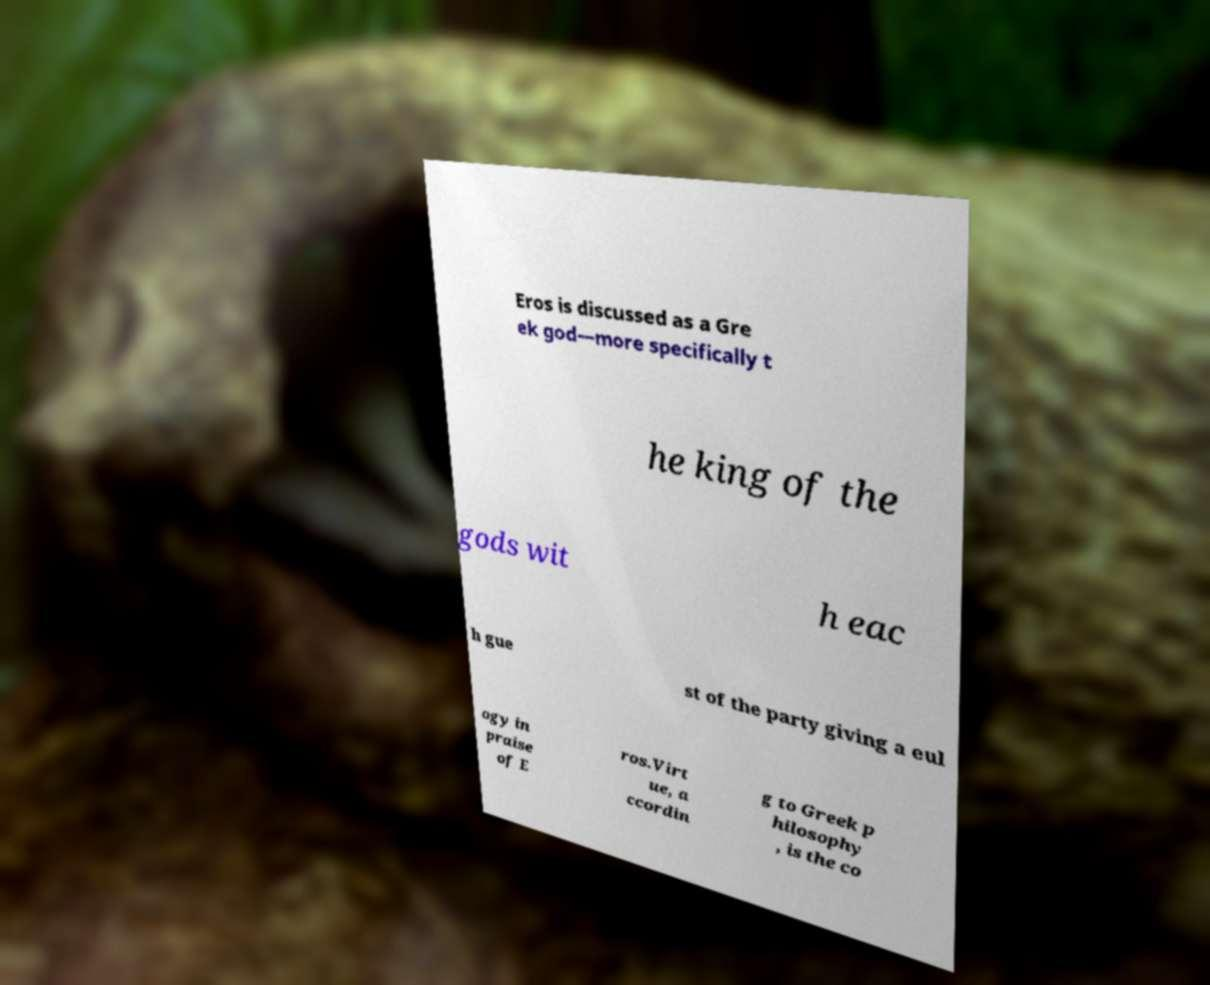For documentation purposes, I need the text within this image transcribed. Could you provide that? Eros is discussed as a Gre ek god—more specifically t he king of the gods wit h eac h gue st of the party giving a eul ogy in praise of E ros.Virt ue, a ccordin g to Greek p hilosophy , is the co 